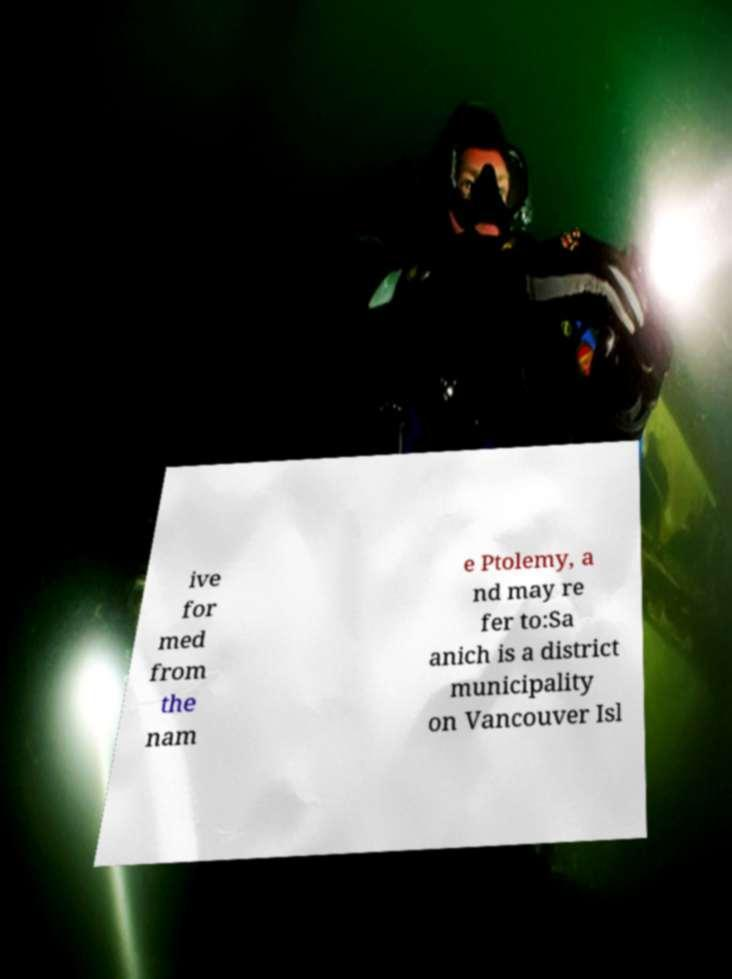I need the written content from this picture converted into text. Can you do that? ive for med from the nam e Ptolemy, a nd may re fer to:Sa anich is a district municipality on Vancouver Isl 